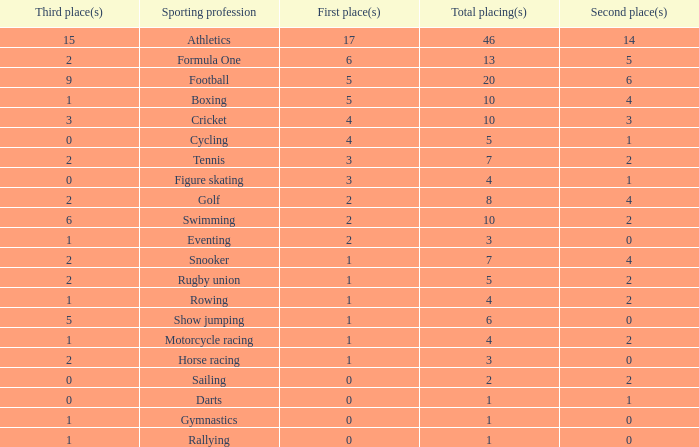How many second place showings does snooker have? 4.0. 